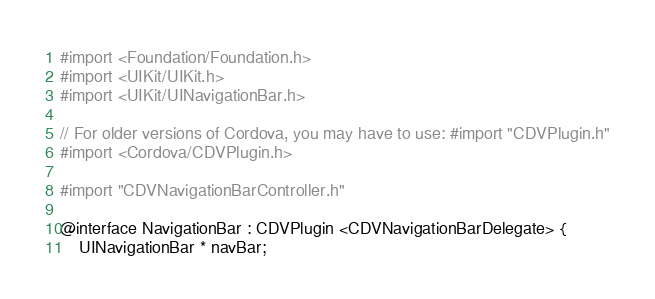Convert code to text. <code><loc_0><loc_0><loc_500><loc_500><_C_>#import <Foundation/Foundation.h>
#import <UIKit/UIKit.h>
#import <UIKit/UINavigationBar.h>

// For older versions of Cordova, you may have to use: #import "CDVPlugin.h"
#import <Cordova/CDVPlugin.h>

#import "CDVNavigationBarController.h"

@interface NavigationBar : CDVPlugin <CDVNavigationBarDelegate> {
    UINavigationBar * navBar;
</code> 